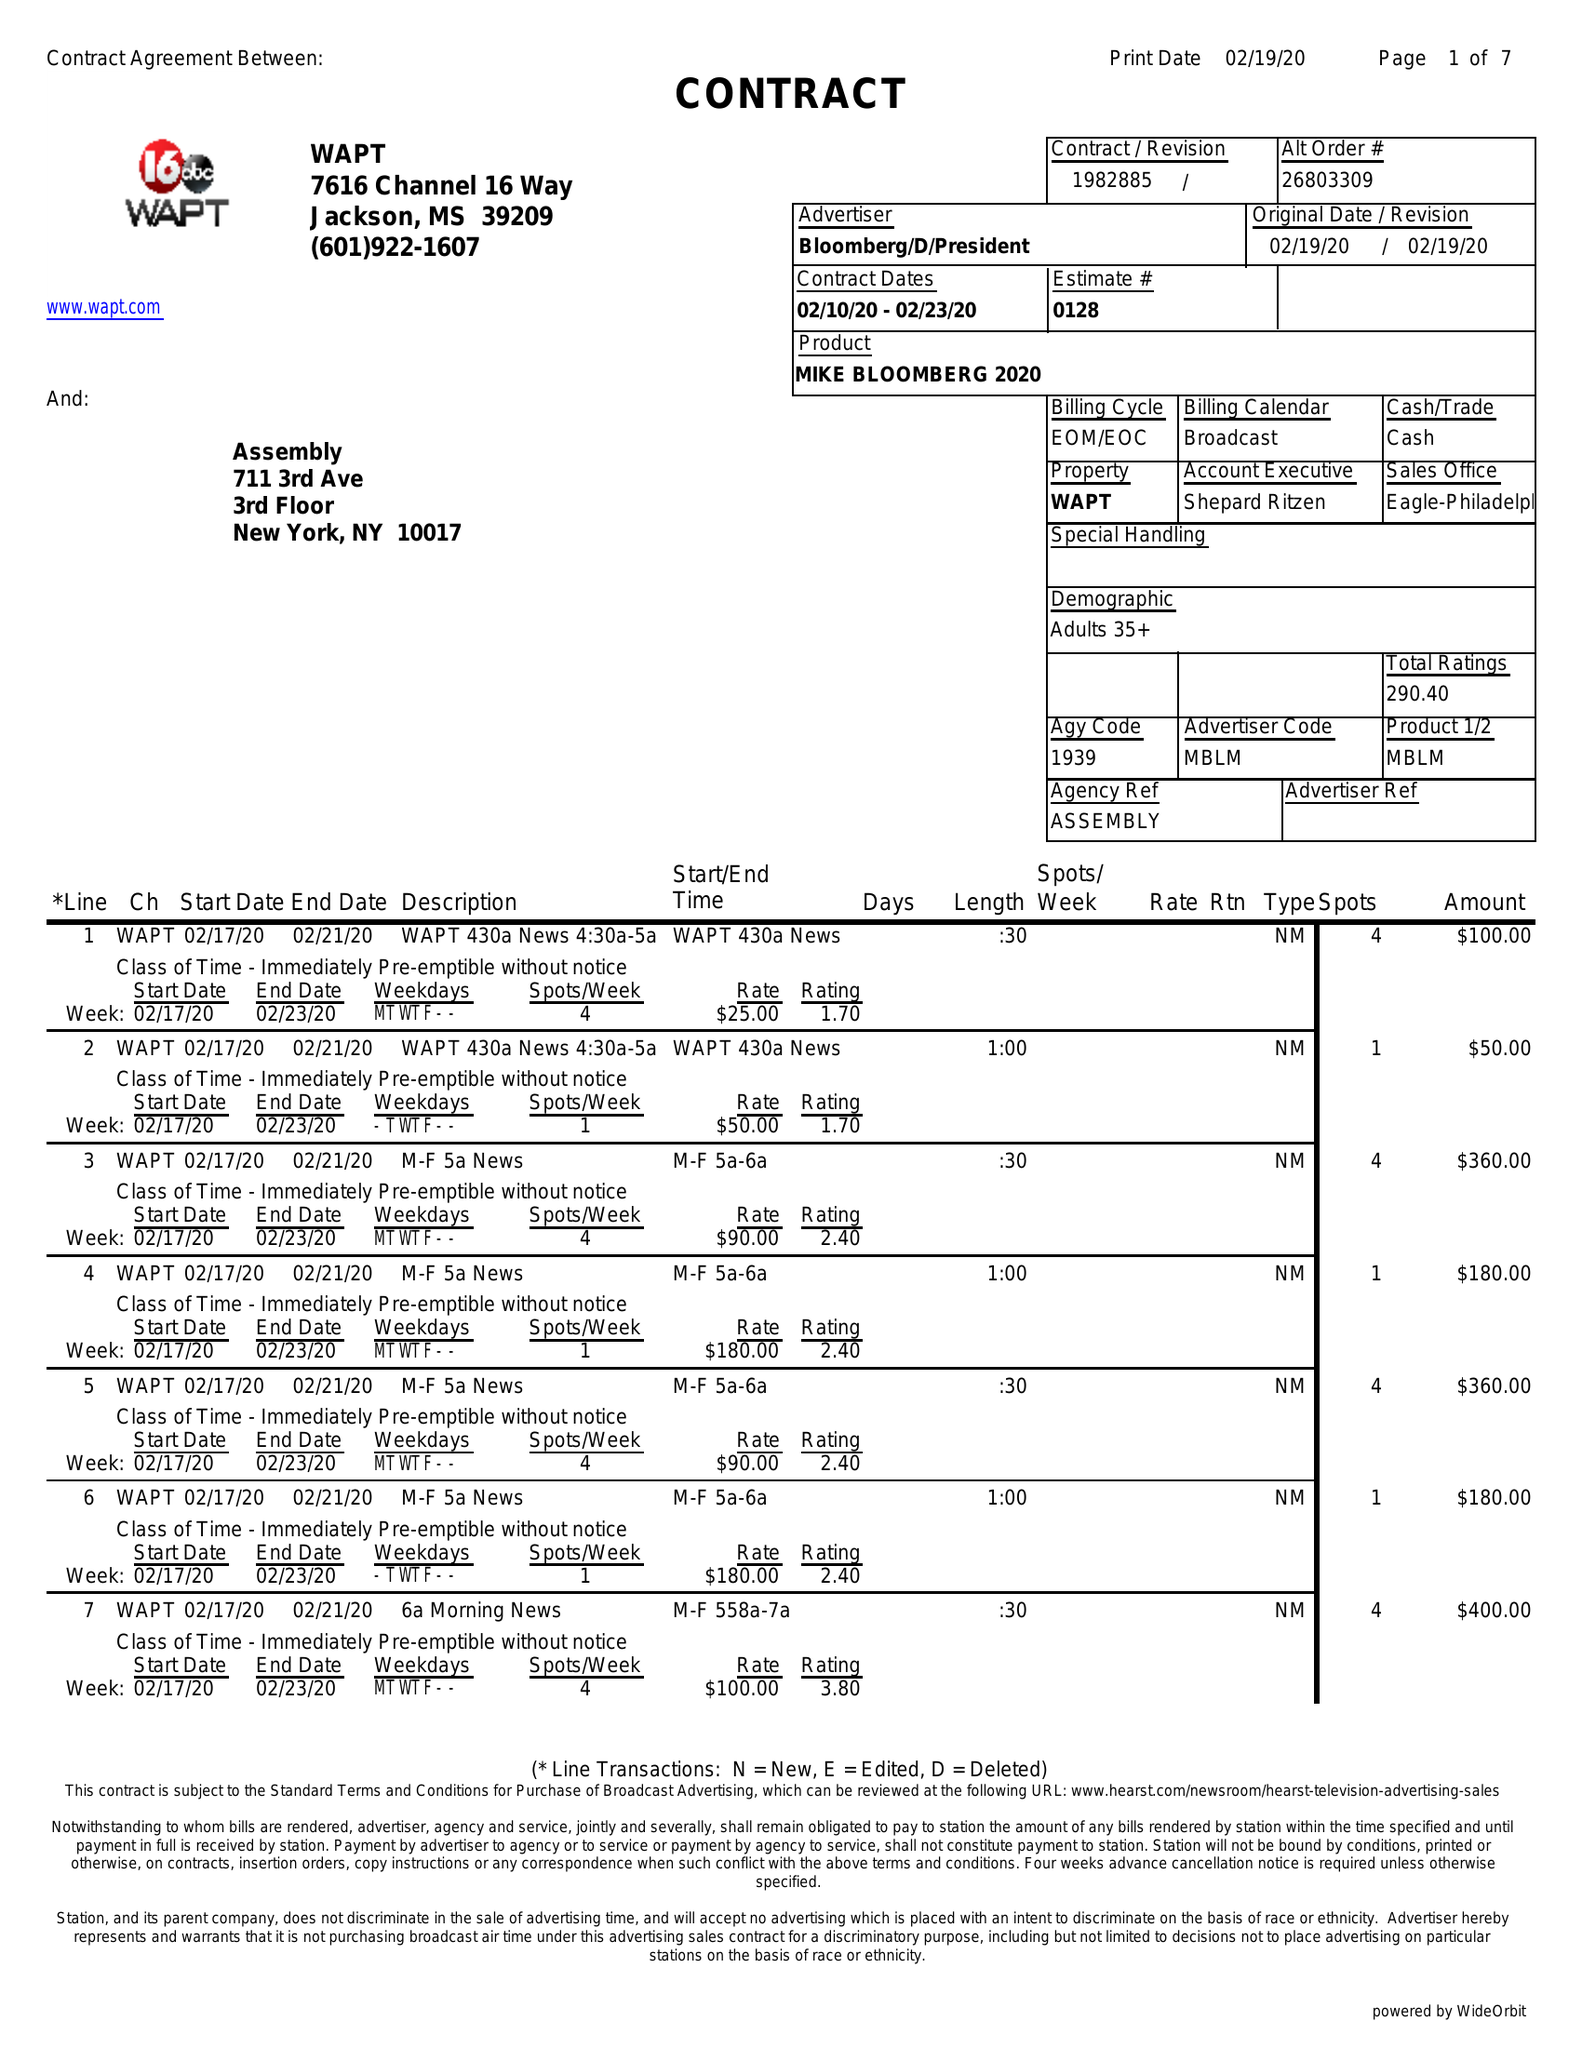What is the value for the flight_from?
Answer the question using a single word or phrase. 02/10/20 